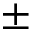Convert formula to latex. <formula><loc_0><loc_0><loc_500><loc_500>\pm</formula> 